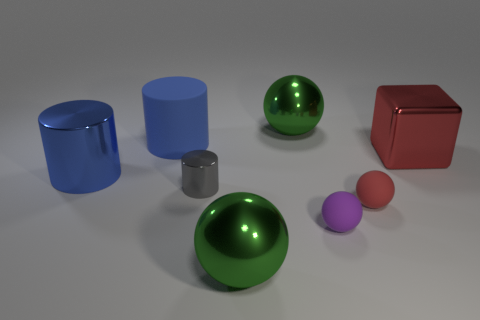What could be the function of these objects, given their shapes and sizes? These objects are likely to be geometric models used for educational purposes or as 3D rendering references. They can demonstrate the properties of shapes, light reflection, shadow casting, and material appearance. Their sizes and shapes aren't practical for everyday functions, which supports the idea that they're meant for demonstration or visual representation. 